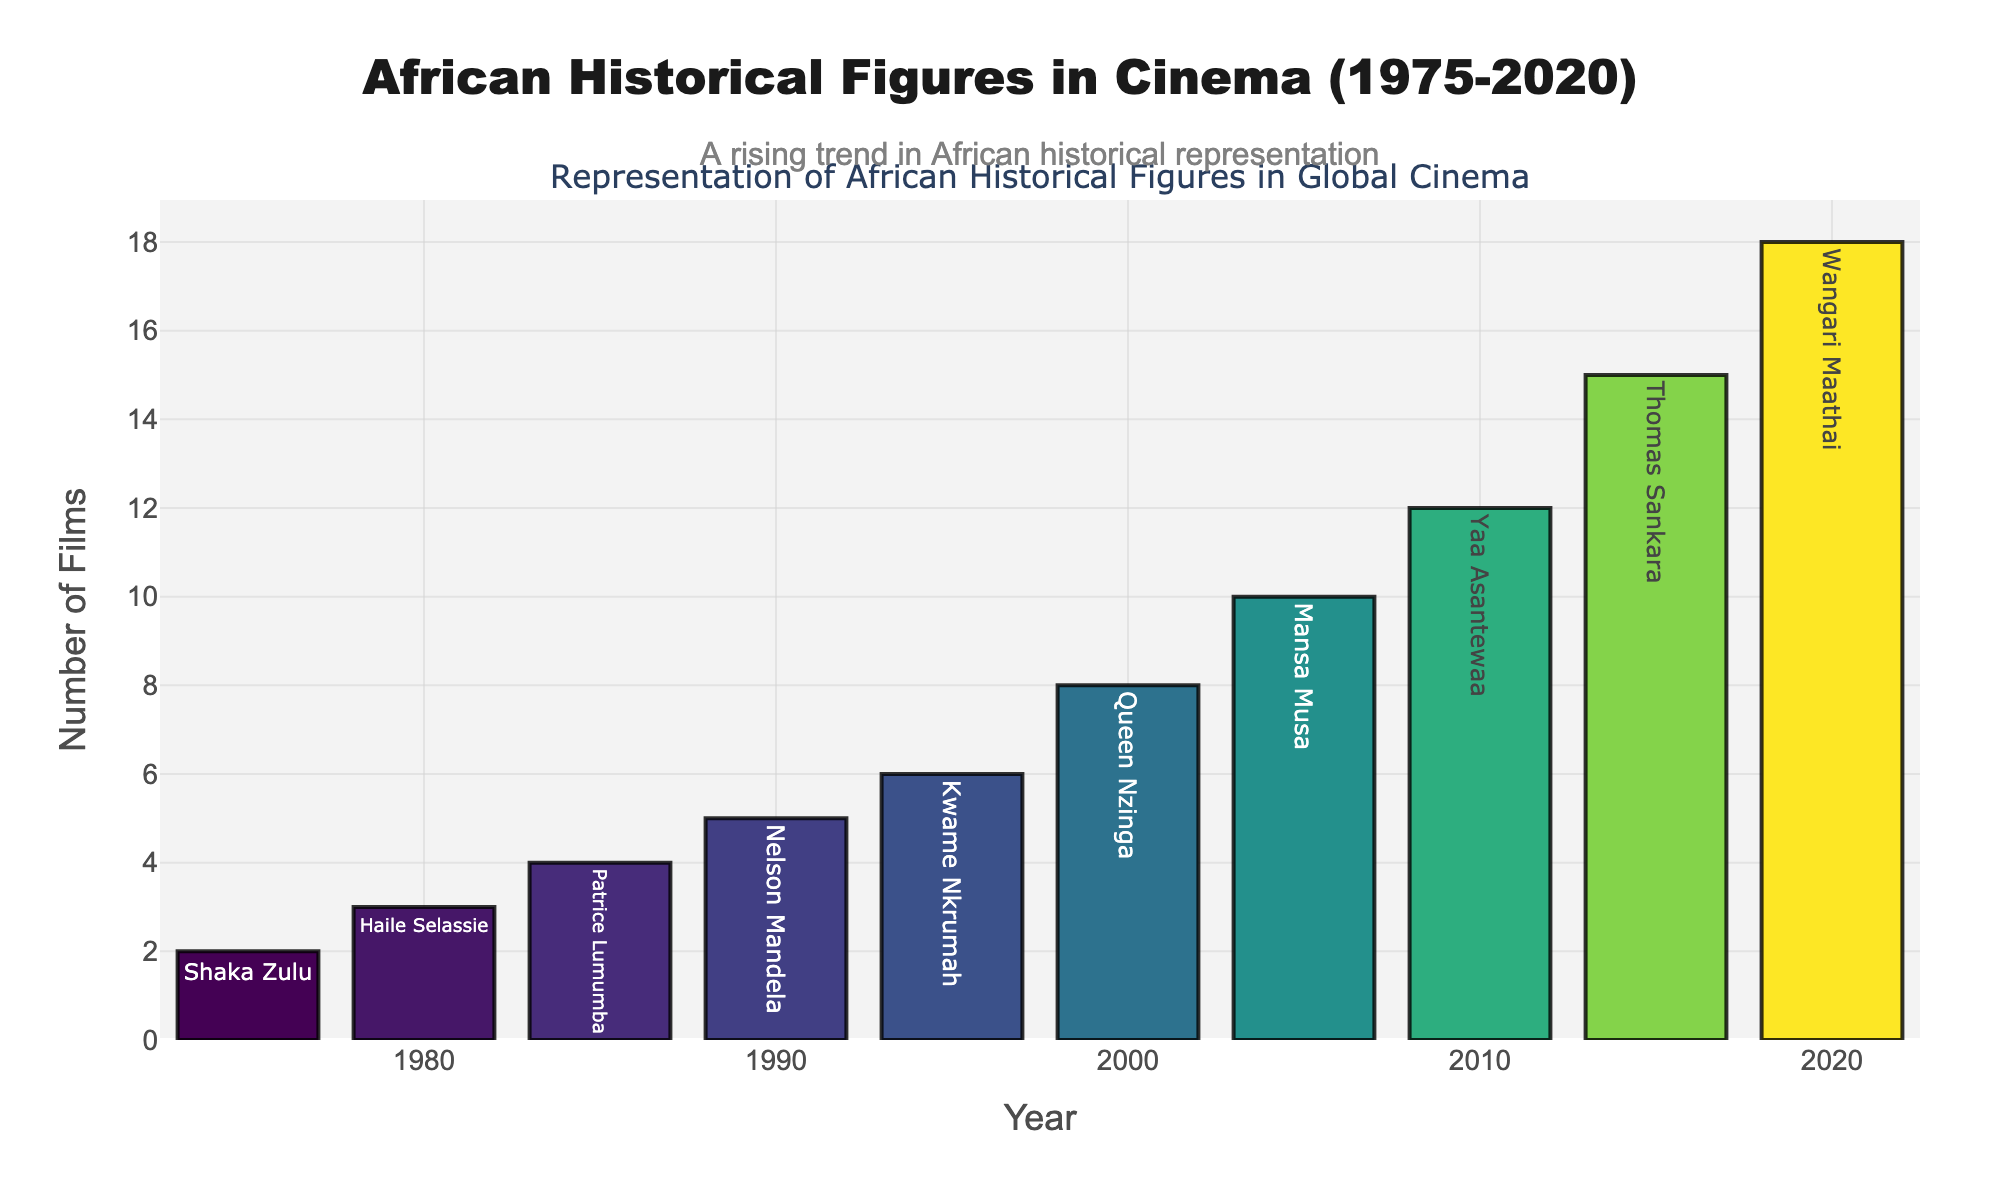Which year had the highest number of films representing African historical figures? Look at the tallest bar in the bar chart. The year with the tallest bar is 2020.
Answer: 2020 How many more films were made in 2020 than in 2000? From the chart, there were 18 films in 2020 and 8 films in 2000. Subtract the number of films in 2000 from the number of films in 2020: 18 - 8 = 10.
Answer: 10 Which historical figure was portrayed in the most films over the years? Look at the bars and their accompanying labels. The highest number of films is 18 in 2020, associated with Wangari Maathai.
Answer: Wangari Maathai By how many films did the representation increase from 1990 to 2005? The number of films in 1990 was 5, and in 2005 it was 10. Subtract the number from 1990 from the number in 2005: 10 - 5 = 5.
Answer: 5 What is the average number of films made per decade? Sum the number of films over the five decades: 2 + 3 + 4 + 5 + 6 + 8 + 10 + 12 + 15 + 18 = 83. Then, divide by 5 to get the average: 83 / 5 = 16.6.
Answer: 16.6 What is the difference in the number of films between 1975 and 2010? In 1975, there were 2 films, and in 2010, there were 12 films. Subtract the 1975 count from the 2010 count: 12 - 2 = 10.
Answer: 10 Compare the representation of Nelson Mandela and Queen Nzinga. In which decade did each figure see representation, and how many films depicted them? Nelson Mandela is portrayed in 5 films in 1990. Queen Nzinga is portrayed in 8 films in 2000.
Answer: Mandela in 1990: 5 films, Nzinga in 2000: 8 films How does the number of films in 1995 compare to 1980? There were 6 films in 1995 and 3 films in 1980. The number in 1995 is double the number in 1980.
Answer: 1995 has double the films as 1980 Which year marked the first double-digit count of films, and how many films were there? The first year with a bar reaching double digits is 2005, with 10 films.
Answer: 2005, 10 films What trend is noticeable in the representation of African historical figures in cinema from 1975 to 2020? The bars in the chart exhibit an upward trend, indicating an increasing number of films over time.
Answer: Increasing trend from 1975 to 2020 